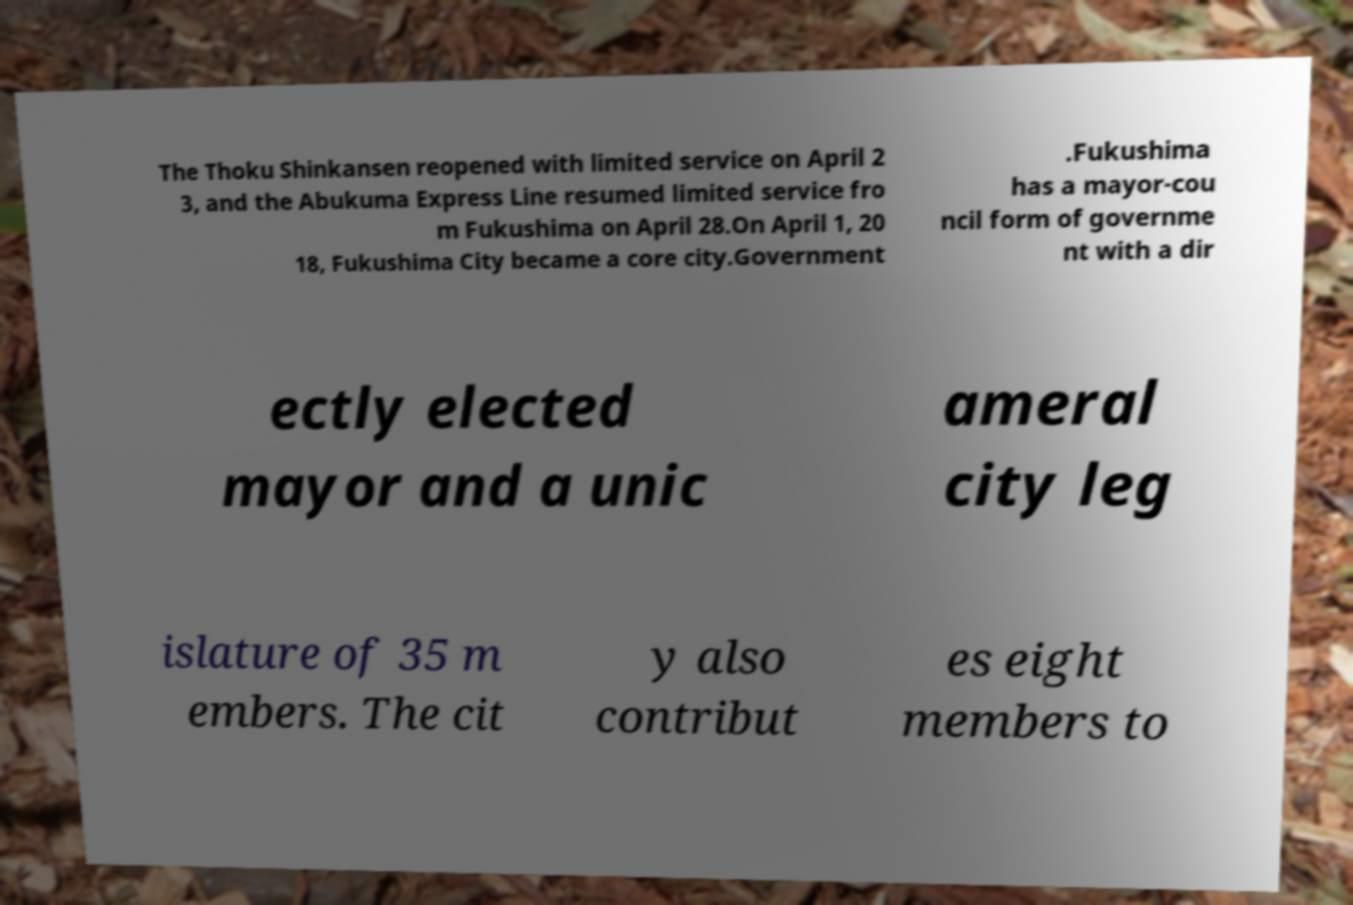Can you accurately transcribe the text from the provided image for me? The Thoku Shinkansen reopened with limited service on April 2 3, and the Abukuma Express Line resumed limited service fro m Fukushima on April 28.On April 1, 20 18, Fukushima City became a core city.Government .Fukushima has a mayor-cou ncil form of governme nt with a dir ectly elected mayor and a unic ameral city leg islature of 35 m embers. The cit y also contribut es eight members to 